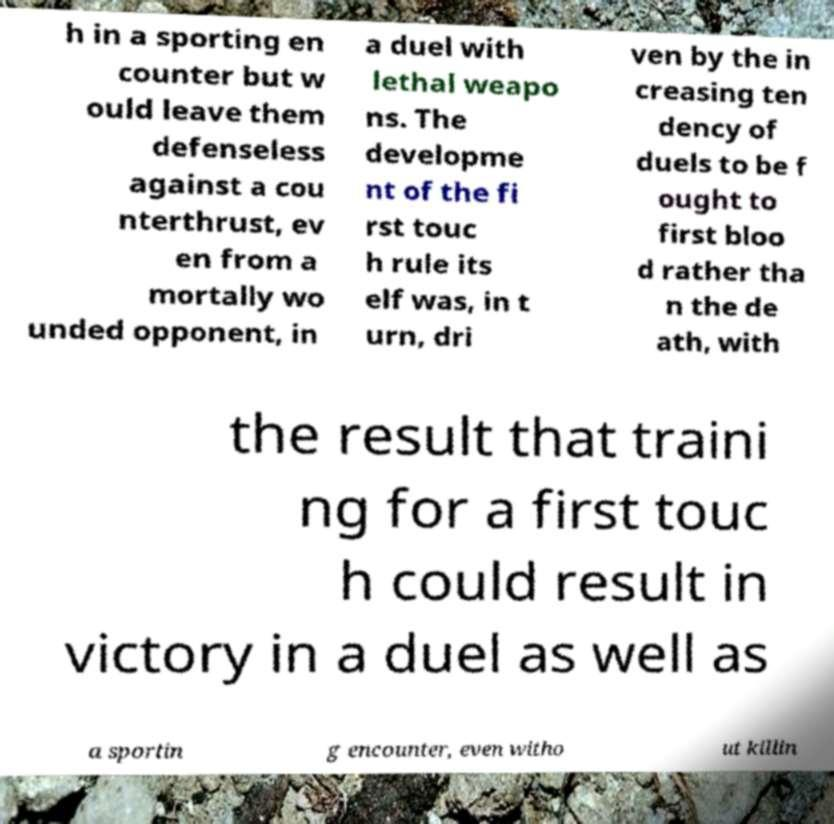Could you extract and type out the text from this image? h in a sporting en counter but w ould leave them defenseless against a cou nterthrust, ev en from a mortally wo unded opponent, in a duel with lethal weapo ns. The developme nt of the fi rst touc h rule its elf was, in t urn, dri ven by the in creasing ten dency of duels to be f ought to first bloo d rather tha n the de ath, with the result that traini ng for a first touc h could result in victory in a duel as well as a sportin g encounter, even witho ut killin 